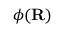<formula> <loc_0><loc_0><loc_500><loc_500>{ \phi } ( R )</formula> 